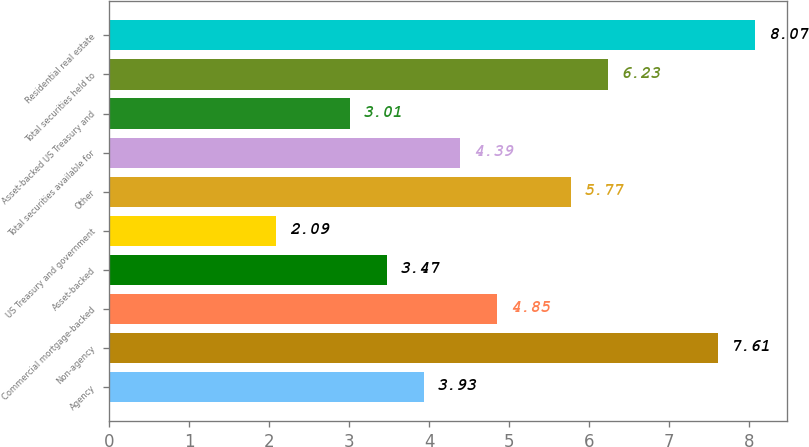Convert chart to OTSL. <chart><loc_0><loc_0><loc_500><loc_500><bar_chart><fcel>Agency<fcel>Non-agency<fcel>Commercial mortgage-backed<fcel>Asset-backed<fcel>US Treasury and government<fcel>Other<fcel>Total securities available for<fcel>Asset-backed US Treasury and<fcel>Total securities held to<fcel>Residential real estate<nl><fcel>3.93<fcel>7.61<fcel>4.85<fcel>3.47<fcel>2.09<fcel>5.77<fcel>4.39<fcel>3.01<fcel>6.23<fcel>8.07<nl></chart> 